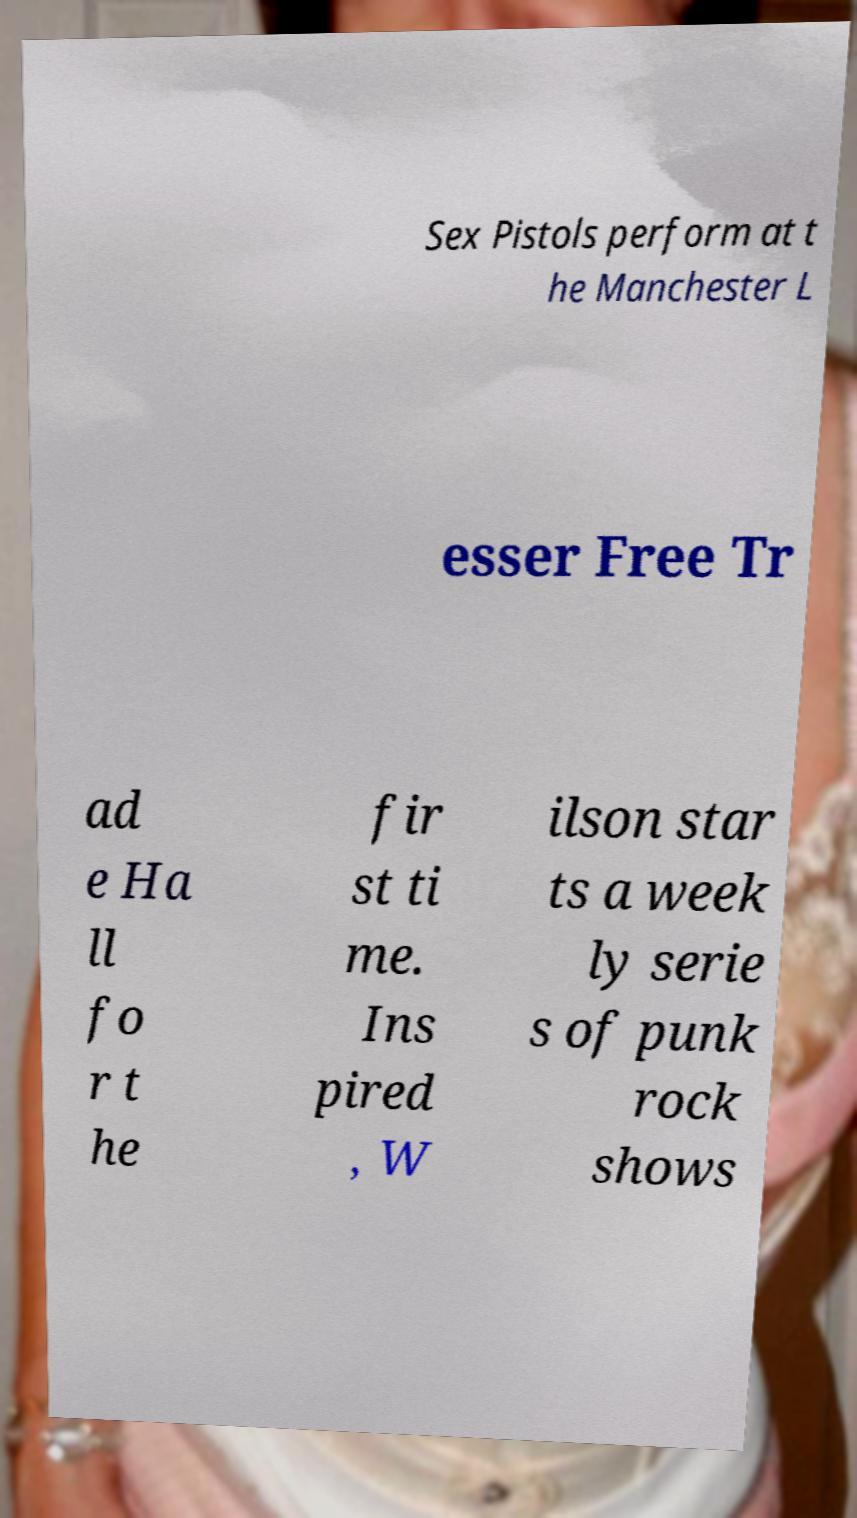I need the written content from this picture converted into text. Can you do that? Sex Pistols perform at t he Manchester L esser Free Tr ad e Ha ll fo r t he fir st ti me. Ins pired , W ilson star ts a week ly serie s of punk rock shows 